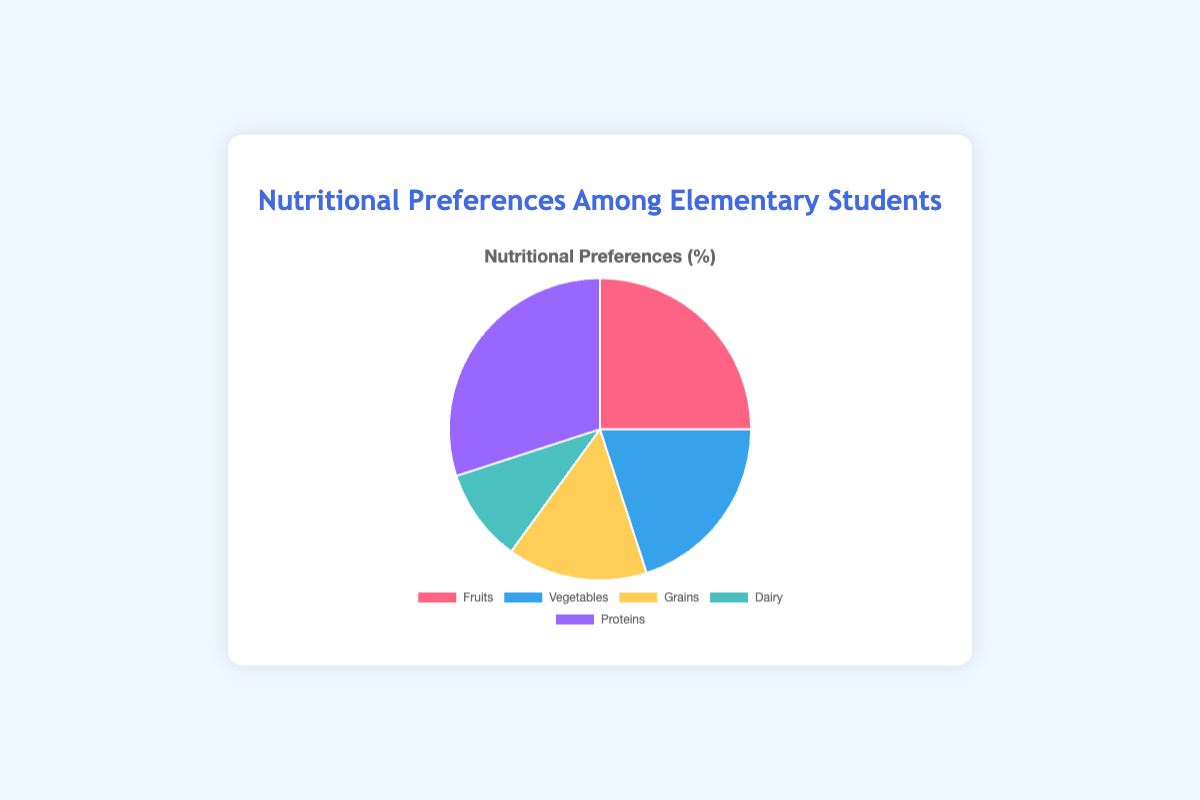What percentage of students prefer fruits? According to the figure, 25% of students prefer fruits. Simply read the section labeled 'Fruits' in the pie chart which states 25%.
Answer: 25% Which nutritional category is the most preferred among elementary students? The pie chart shows the largest section labeled 'Proteins' with 30%, making it the most preferred nutritional category.
Answer: Proteins How many more students prefer proteins compared to dairy? The figure shows that 30% of students prefer proteins and 10% prefer dairy. Subtract 10 from 30 to find the difference.
Answer: 20% What is the combined percentage of students who prefer vegetables and grains? The chart indicates that 20% of students prefer vegetables and 15% prefer grains. Add these percentages together to find the total. 20 + 15 = 35
Answer: 35% Which nutritional category is least favored by students? By looking at the pie chart, the smallest section belongs to 'Dairy', which has 10%.
Answer: Dairy Are there more students who prefer fruits or grains? Fruits have a 25% preference, while grains have a 15% preference as shown in the pie chart. Compare 25 to 15.
Answer: Fruits What is the average preference percentage, based on all categories? Add the percentages of all categories: 25 + 20 + 15 + 10 + 30 = 100, then divide by the number of categories, which is 5. 100 / 5 = 20
Answer: 20 How do the preferences for fruits and vegetables compare? According to the chart, fruits are preferred by 25% of students and vegetables by 20%. Compare these two numbers.
Answer: Fruits are more preferred Which color section represents grains and what percentage does it cover? The section representing grains is colored yellow and accounts for 15% of the pie chart.
Answer: Yellow, 15% If the preference for dairy increased by 5%, how would the overall percentage distribution change? Currently, the preference for dairy is 10%. If it increased by 5%, it would be 10 + 5 = 15%. This would affect the pie chart's total distribution, increasing dairy to 15% and decreasing the total percentage available for other categories by 5%, requiring recalculation of remaining percentages.
Answer: Dairy would be 15%, others would need adjusting 